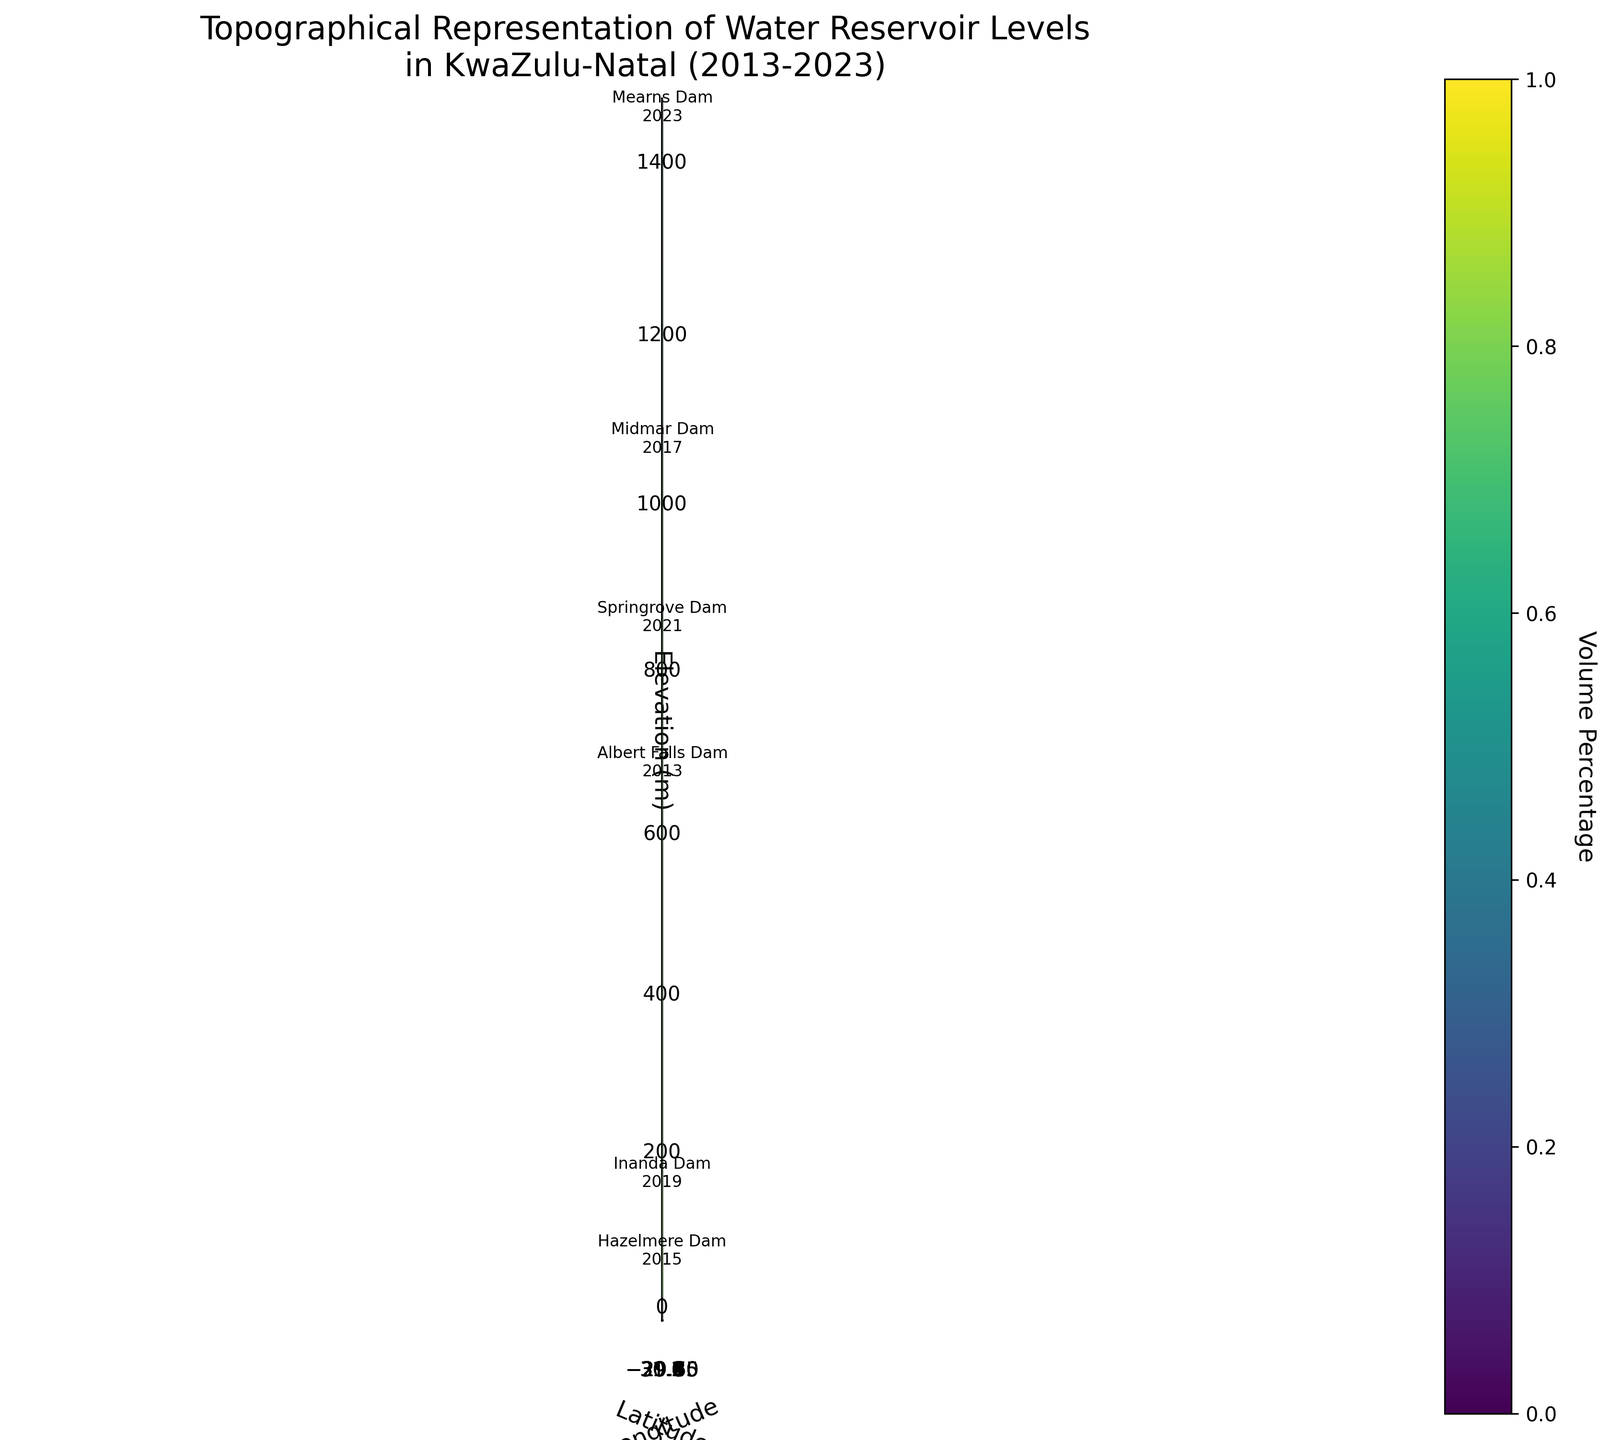What is the title of the figure? The title is located at the top of the figure and usually provides an overview of the content being represented. In this case, it mentions the topographical representation and the time frame.
Answer: Topographical Representation of Water Reservoir Levels in KwaZulu-Natal (2013-2023) How many reservoirs are represented in the figure? Count the number of labeled data points in the figure. Each label corresponds to a reservoir.
Answer: 6 Which reservoir has the highest elevation and what is its elevation? Look at the z-axis, which represents elevation, and identify the highest data point. Then, check its label for the reservoir name and elevation.
Answer: Mearns Dam, 1433 meters Between which years does the data range? Look at the reservoir labels to identify the earliest and latest years mentioned.
Answer: 2013 to 2023 Which reservoir had the highest volume percentage, and what was that percentage? Using the color bar on the right side of the figure, identify the reservoir with the darkest color, then check its corresponding label for the volume percentage.
Answer: Inanda Dam, 91.2% How does the volume percentage of Hazelmere Dam in 2015 compare to that of Springrove Dam in 2021? Identify the color and percentage values for Hazelmere Dam (2015) and Springrove Dam (2021). Compare the two percentages to determine the relationship.
Answer: Hazelmere Dam (62.3%) is lower than Springrove Dam (73.6%) Which reservoir is located at the most southern latitude? Look at the y-axis, which represents latitude, and identify the reservoir situated furthest south (lowest latitude).
Answer: Hazelmere Dam What is the average elevation of all the reservoirs? Sum up the elevation values of all reservoirs and divide by the number of reservoirs. Calculation: (655 + 39 + 1046 + 139 + 832 + 1433) / 6.
Answer: 857.3 meters Did the volume percentage increase or decrease for reservoirs from 2017 to 2019? Compare the volume percentages of the reservoirs present in 2017 and 2019 by looking at their colors and labels.
Answer: It increased (Midmar Dam: 85.7% in 2017 to Inanda Dam: 91.2% in 2019) Is there any reservoir that maintained a similar volume percentage over the years? If yes, which ones? Compare the volume percentages of each reservoir across different years and identify if any stayed roughly the same.
Answer: No 